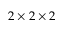Convert formula to latex. <formula><loc_0><loc_0><loc_500><loc_500>2 \times 2 \times 2</formula> 